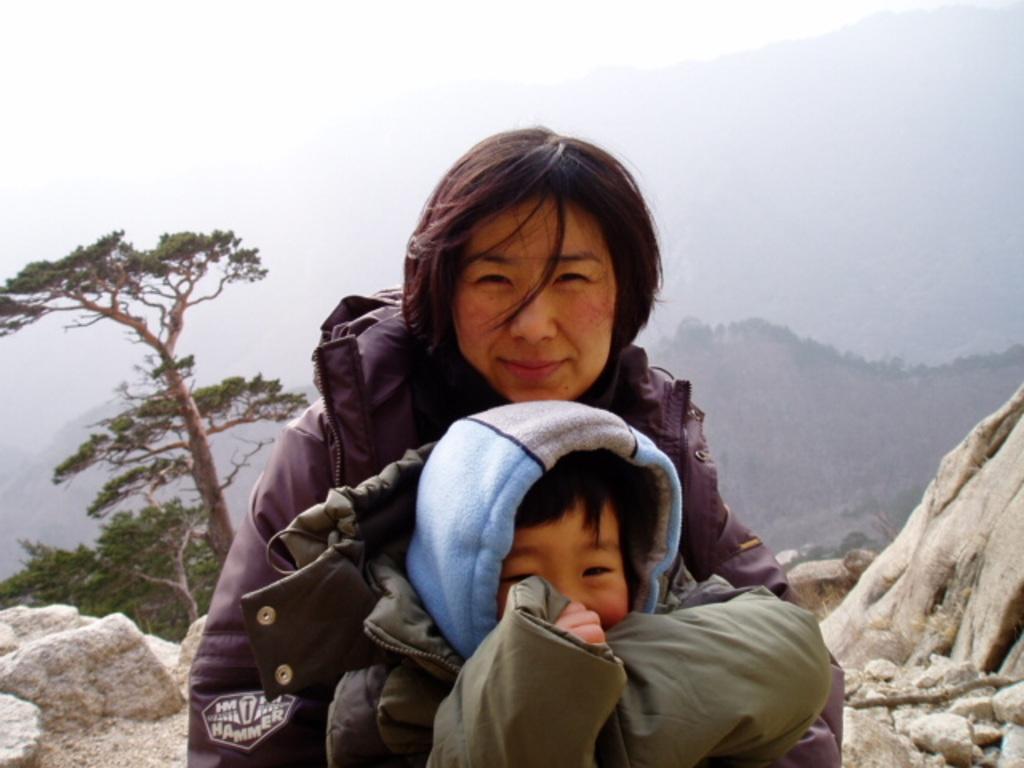Could you give a brief overview of what you see in this image? In this image, I can see a woman and a kid smiling. At the bottom of the image, I think these are the rocks. On the left side of the image, It looks like a tree with branches and leaves. In the background, I think these are the mountains. At the top of the image, I can see the sky. 